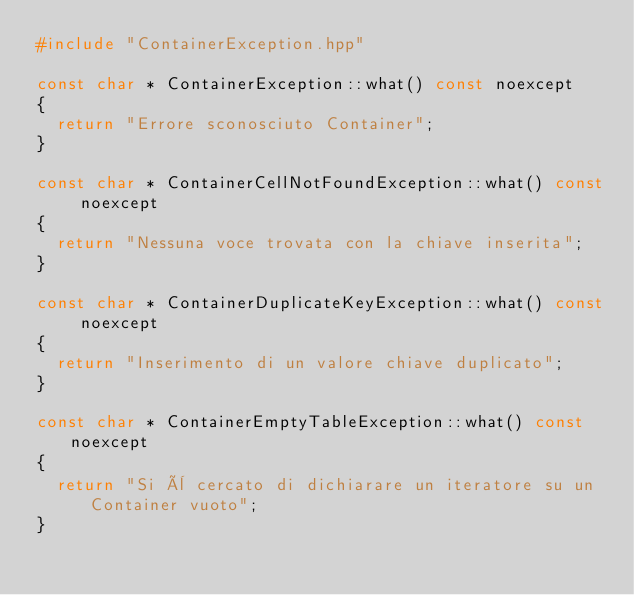<code> <loc_0><loc_0><loc_500><loc_500><_C++_>#include "ContainerException.hpp"

const char * ContainerException::what() const noexcept
{
  return "Errore sconosciuto Container";
}

const char * ContainerCellNotFoundException::what() const noexcept
{
  return "Nessuna voce trovata con la chiave inserita";
}

const char * ContainerDuplicateKeyException::what() const noexcept
{
  return "Inserimento di un valore chiave duplicato";
}

const char * ContainerEmptyTableException::what() const noexcept
{
  return "Si è cercato di dichiarare un iteratore su un Container vuoto";
}
</code> 